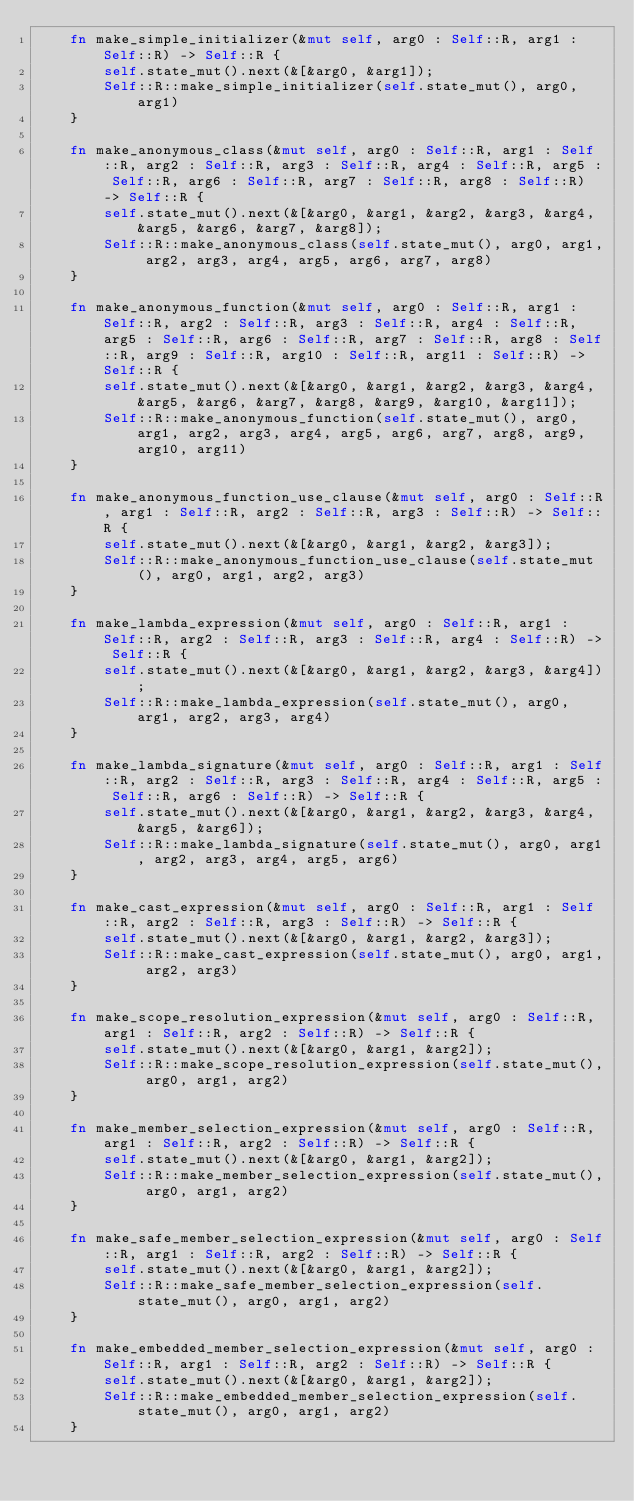Convert code to text. <code><loc_0><loc_0><loc_500><loc_500><_Rust_>    fn make_simple_initializer(&mut self, arg0 : Self::R, arg1 : Self::R) -> Self::R {
        self.state_mut().next(&[&arg0, &arg1]);
        Self::R::make_simple_initializer(self.state_mut(), arg0, arg1)
    }

    fn make_anonymous_class(&mut self, arg0 : Self::R, arg1 : Self::R, arg2 : Self::R, arg3 : Self::R, arg4 : Self::R, arg5 : Self::R, arg6 : Self::R, arg7 : Self::R, arg8 : Self::R) -> Self::R {
        self.state_mut().next(&[&arg0, &arg1, &arg2, &arg3, &arg4, &arg5, &arg6, &arg7, &arg8]);
        Self::R::make_anonymous_class(self.state_mut(), arg0, arg1, arg2, arg3, arg4, arg5, arg6, arg7, arg8)
    }

    fn make_anonymous_function(&mut self, arg0 : Self::R, arg1 : Self::R, arg2 : Self::R, arg3 : Self::R, arg4 : Self::R, arg5 : Self::R, arg6 : Self::R, arg7 : Self::R, arg8 : Self::R, arg9 : Self::R, arg10 : Self::R, arg11 : Self::R) -> Self::R {
        self.state_mut().next(&[&arg0, &arg1, &arg2, &arg3, &arg4, &arg5, &arg6, &arg7, &arg8, &arg9, &arg10, &arg11]);
        Self::R::make_anonymous_function(self.state_mut(), arg0, arg1, arg2, arg3, arg4, arg5, arg6, arg7, arg8, arg9, arg10, arg11)
    }

    fn make_anonymous_function_use_clause(&mut self, arg0 : Self::R, arg1 : Self::R, arg2 : Self::R, arg3 : Self::R) -> Self::R {
        self.state_mut().next(&[&arg0, &arg1, &arg2, &arg3]);
        Self::R::make_anonymous_function_use_clause(self.state_mut(), arg0, arg1, arg2, arg3)
    }

    fn make_lambda_expression(&mut self, arg0 : Self::R, arg1 : Self::R, arg2 : Self::R, arg3 : Self::R, arg4 : Self::R) -> Self::R {
        self.state_mut().next(&[&arg0, &arg1, &arg2, &arg3, &arg4]);
        Self::R::make_lambda_expression(self.state_mut(), arg0, arg1, arg2, arg3, arg4)
    }

    fn make_lambda_signature(&mut self, arg0 : Self::R, arg1 : Self::R, arg2 : Self::R, arg3 : Self::R, arg4 : Self::R, arg5 : Self::R, arg6 : Self::R) -> Self::R {
        self.state_mut().next(&[&arg0, &arg1, &arg2, &arg3, &arg4, &arg5, &arg6]);
        Self::R::make_lambda_signature(self.state_mut(), arg0, arg1, arg2, arg3, arg4, arg5, arg6)
    }

    fn make_cast_expression(&mut self, arg0 : Self::R, arg1 : Self::R, arg2 : Self::R, arg3 : Self::R) -> Self::R {
        self.state_mut().next(&[&arg0, &arg1, &arg2, &arg3]);
        Self::R::make_cast_expression(self.state_mut(), arg0, arg1, arg2, arg3)
    }

    fn make_scope_resolution_expression(&mut self, arg0 : Self::R, arg1 : Self::R, arg2 : Self::R) -> Self::R {
        self.state_mut().next(&[&arg0, &arg1, &arg2]);
        Self::R::make_scope_resolution_expression(self.state_mut(), arg0, arg1, arg2)
    }

    fn make_member_selection_expression(&mut self, arg0 : Self::R, arg1 : Self::R, arg2 : Self::R) -> Self::R {
        self.state_mut().next(&[&arg0, &arg1, &arg2]);
        Self::R::make_member_selection_expression(self.state_mut(), arg0, arg1, arg2)
    }

    fn make_safe_member_selection_expression(&mut self, arg0 : Self::R, arg1 : Self::R, arg2 : Self::R) -> Self::R {
        self.state_mut().next(&[&arg0, &arg1, &arg2]);
        Self::R::make_safe_member_selection_expression(self.state_mut(), arg0, arg1, arg2)
    }

    fn make_embedded_member_selection_expression(&mut self, arg0 : Self::R, arg1 : Self::R, arg2 : Self::R) -> Self::R {
        self.state_mut().next(&[&arg0, &arg1, &arg2]);
        Self::R::make_embedded_member_selection_expression(self.state_mut(), arg0, arg1, arg2)
    }
</code> 